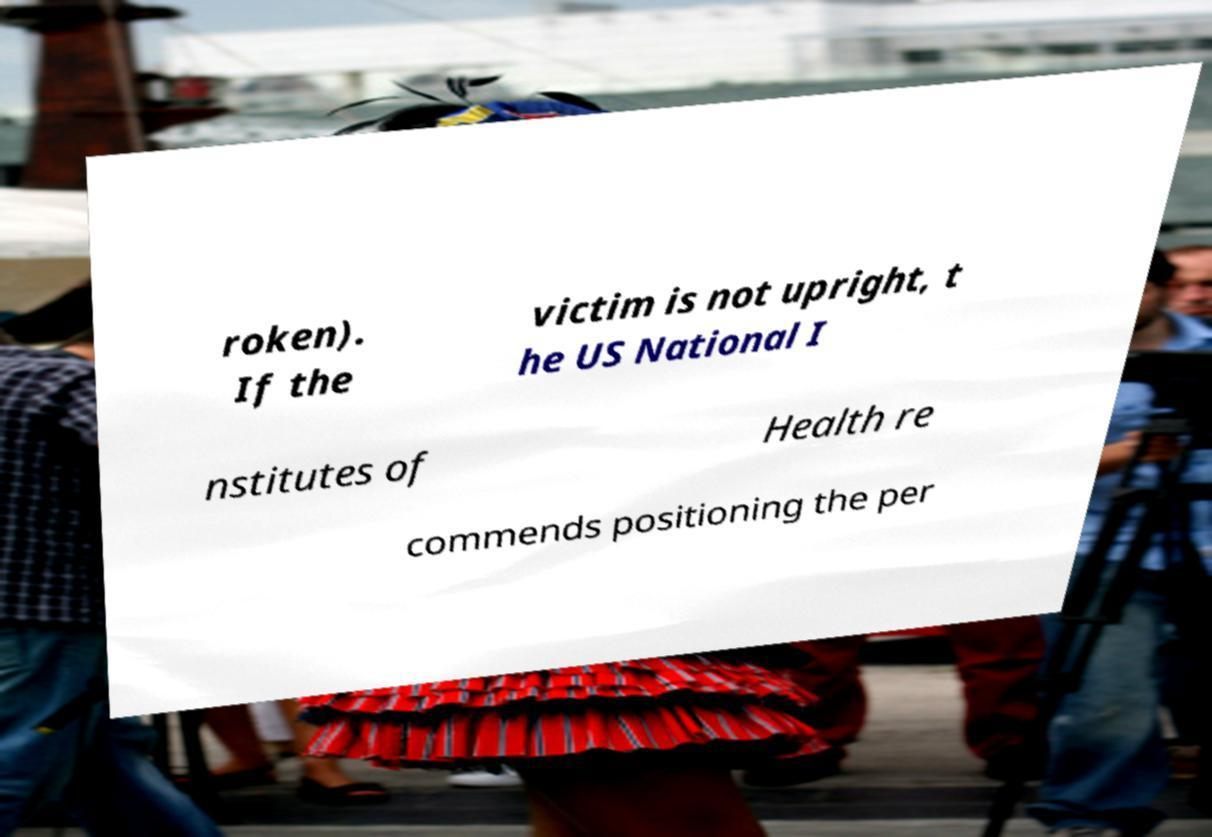Could you assist in decoding the text presented in this image and type it out clearly? roken). If the victim is not upright, t he US National I nstitutes of Health re commends positioning the per 